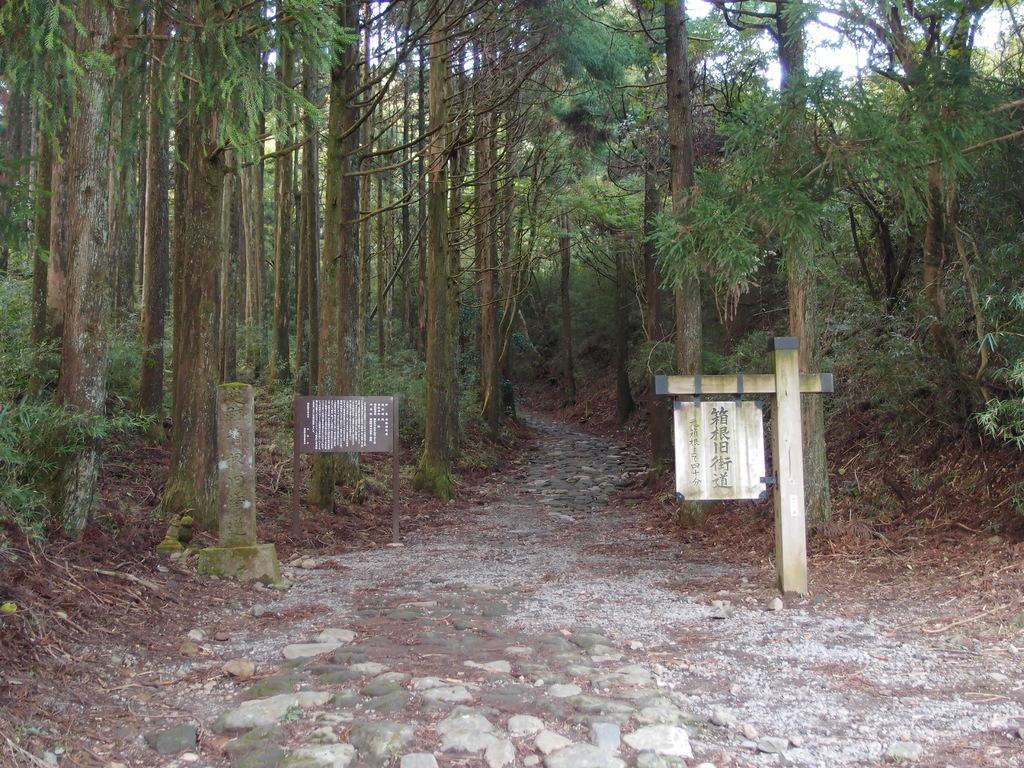In one or two sentences, can you explain what this image depicts? In this image we can see the sign boards to the poles with some text on them. We can also see some stones, the pathway, the bark of the trees, a group of trees and the sky. 